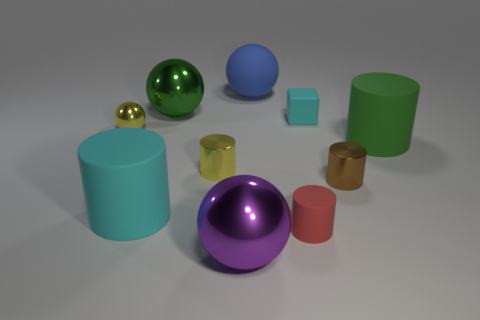Subtract 1 balls. How many balls are left? 3 Subtract all brown cylinders. How many cylinders are left? 4 Subtract all yellow cylinders. How many cylinders are left? 4 Subtract all brown spheres. Subtract all cyan cylinders. How many spheres are left? 4 Subtract all balls. How many objects are left? 6 Add 9 large yellow metal spheres. How many large yellow metal spheres exist? 9 Subtract 1 yellow cylinders. How many objects are left? 9 Subtract all red rubber cylinders. Subtract all tiny yellow metallic objects. How many objects are left? 7 Add 3 tiny blocks. How many tiny blocks are left? 4 